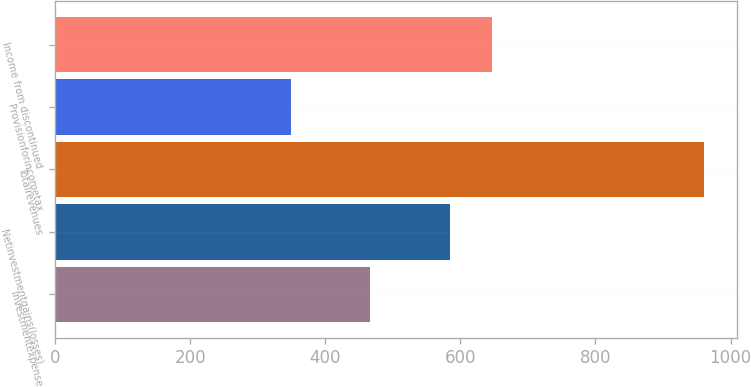<chart> <loc_0><loc_0><loc_500><loc_500><bar_chart><fcel>Investmentexpense<fcel>Netinvestmentgains(losses)<fcel>Totalrevenues<fcel>Provisionforincometax<fcel>Income from discontinued<nl><fcel>466<fcel>585<fcel>961<fcel>349<fcel>646.2<nl></chart> 